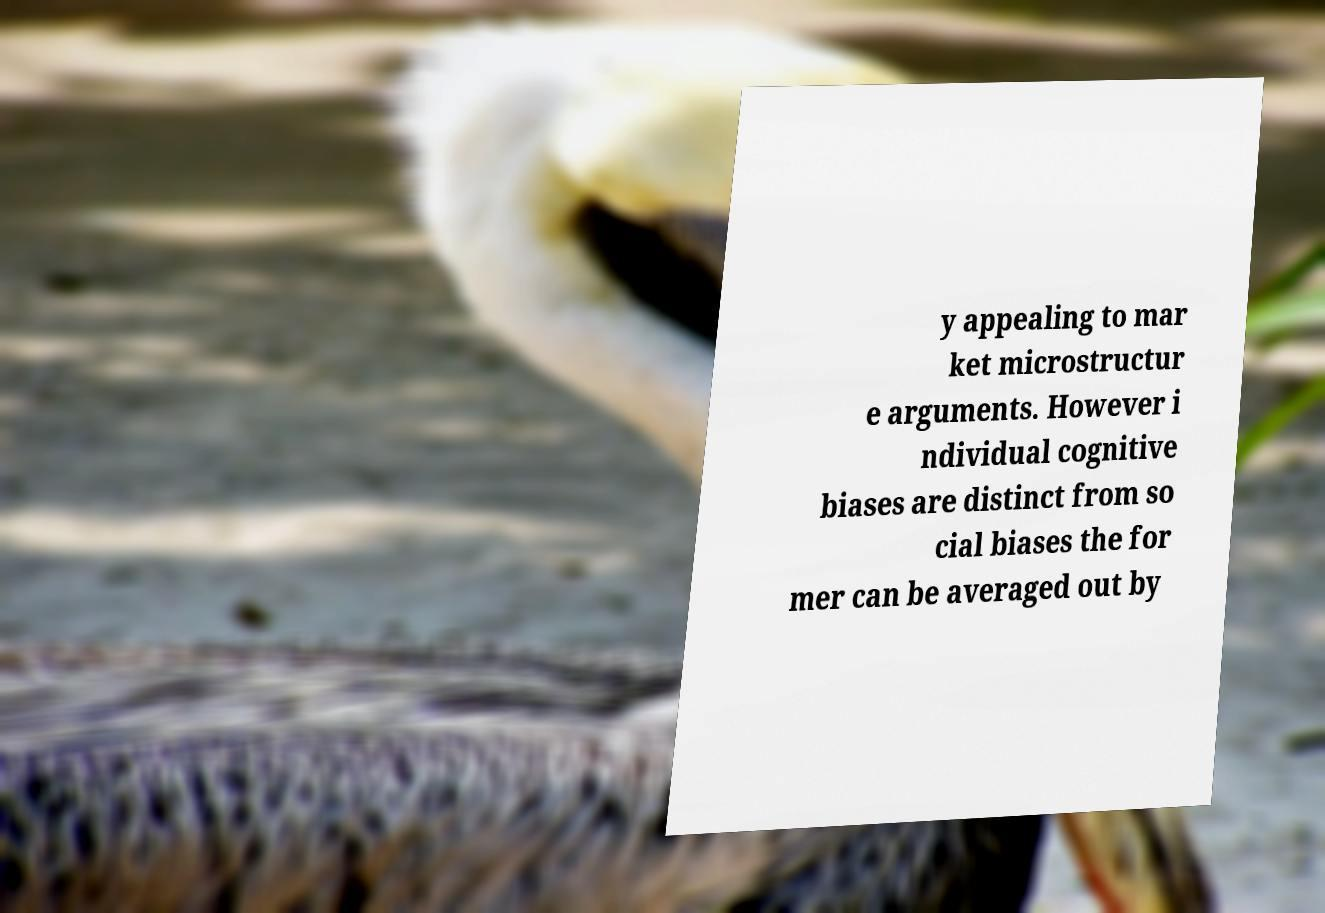Could you assist in decoding the text presented in this image and type it out clearly? y appealing to mar ket microstructur e arguments. However i ndividual cognitive biases are distinct from so cial biases the for mer can be averaged out by 